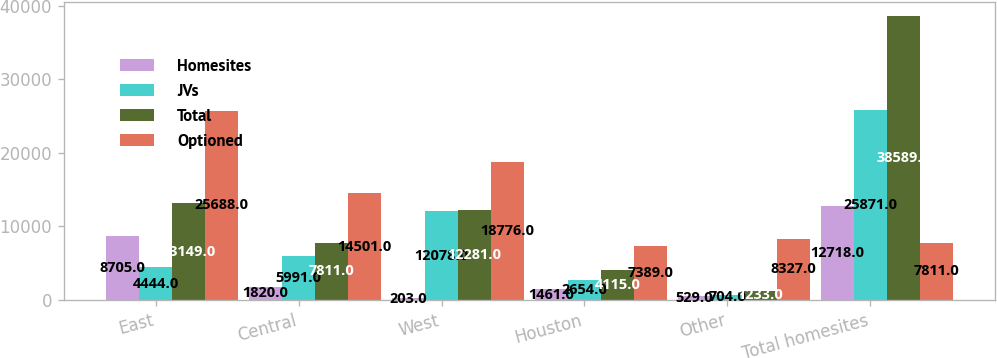<chart> <loc_0><loc_0><loc_500><loc_500><stacked_bar_chart><ecel><fcel>East<fcel>Central<fcel>West<fcel>Houston<fcel>Other<fcel>Total homesites<nl><fcel>Homesites<fcel>8705<fcel>1820<fcel>203<fcel>1461<fcel>529<fcel>12718<nl><fcel>JVs<fcel>4444<fcel>5991<fcel>12078<fcel>2654<fcel>704<fcel>25871<nl><fcel>Total<fcel>13149<fcel>7811<fcel>12281<fcel>4115<fcel>1233<fcel>38589<nl><fcel>Optioned<fcel>25688<fcel>14501<fcel>18776<fcel>7389<fcel>8327<fcel>7811<nl></chart> 